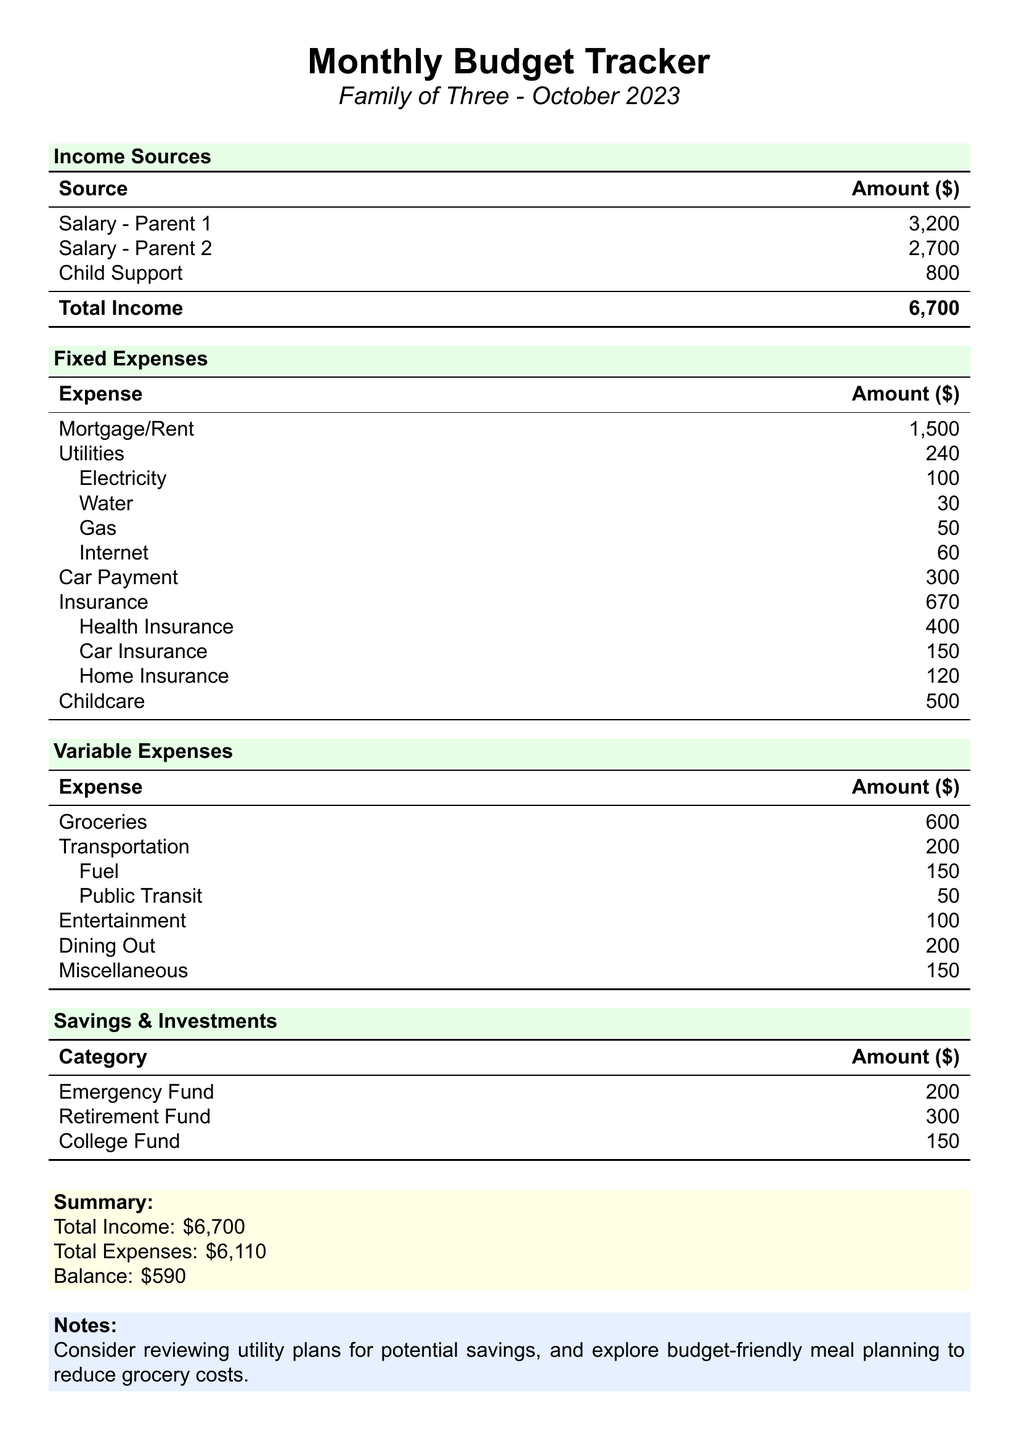What is the total income? The total income is the sum of all income sources in the document: 3200 + 2700 + 800 = 6700.
Answer: 6700 What is the fixed expense for childcare? The fixed expense listed for childcare in the document is directly mentioned.
Answer: 500 How much was spent on groceries? The amount spent on groceries is specified in the variable expenses section of the document.
Answer: 600 What is the balance at the end of the month? The balance is calculated by subtracting total expenses from total income: 6700 - 6110 = 590.
Answer: 590 What is the amount allocated for the retirement fund? The amount allocated for the retirement fund is listed under savings and investments.
Answer: 300 How much is spent in total on utilities? The total amount spent on utilities is the sum of electricity, water, gas, and internet.
Answer: 480 What is the total amount for all variable expenses? The total variable expenses are calculated by summing all the variable cost items.
Answer: 1300 How much is the insurance total? The insurance total is accumulated from health, car, and home insurance, which is mentioned in fixed expenses.
Answer: 670 What is the amount in the emergency fund? The amount in the emergency fund is clearly listed in the savings and investments section.
Answer: 200 